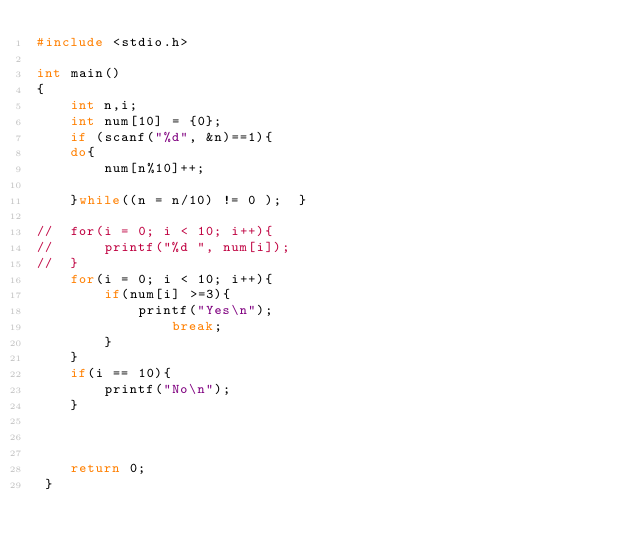Convert code to text. <code><loc_0><loc_0><loc_500><loc_500><_C_>#include <stdio.h>  
  
int main()  
{  
    int n,i;  
    int num[10] = {0};  
    if (scanf("%d", &n)==1){  
    do{  
        num[n%10]++;  
      
    }while((n = n/10) != 0 );  }
  
//  for(i = 0; i < 10; i++){  
//      printf("%d ", num[i]);  
//  }  
    for(i = 0; i < 10; i++){  
        if(num[i] >=3){  
            printf("Yes\n");  
                break;  
        }  
    }  
    if(i == 10){  
        printf("No\n");  
    }  
    
  
  
    return 0;  
 }</code> 